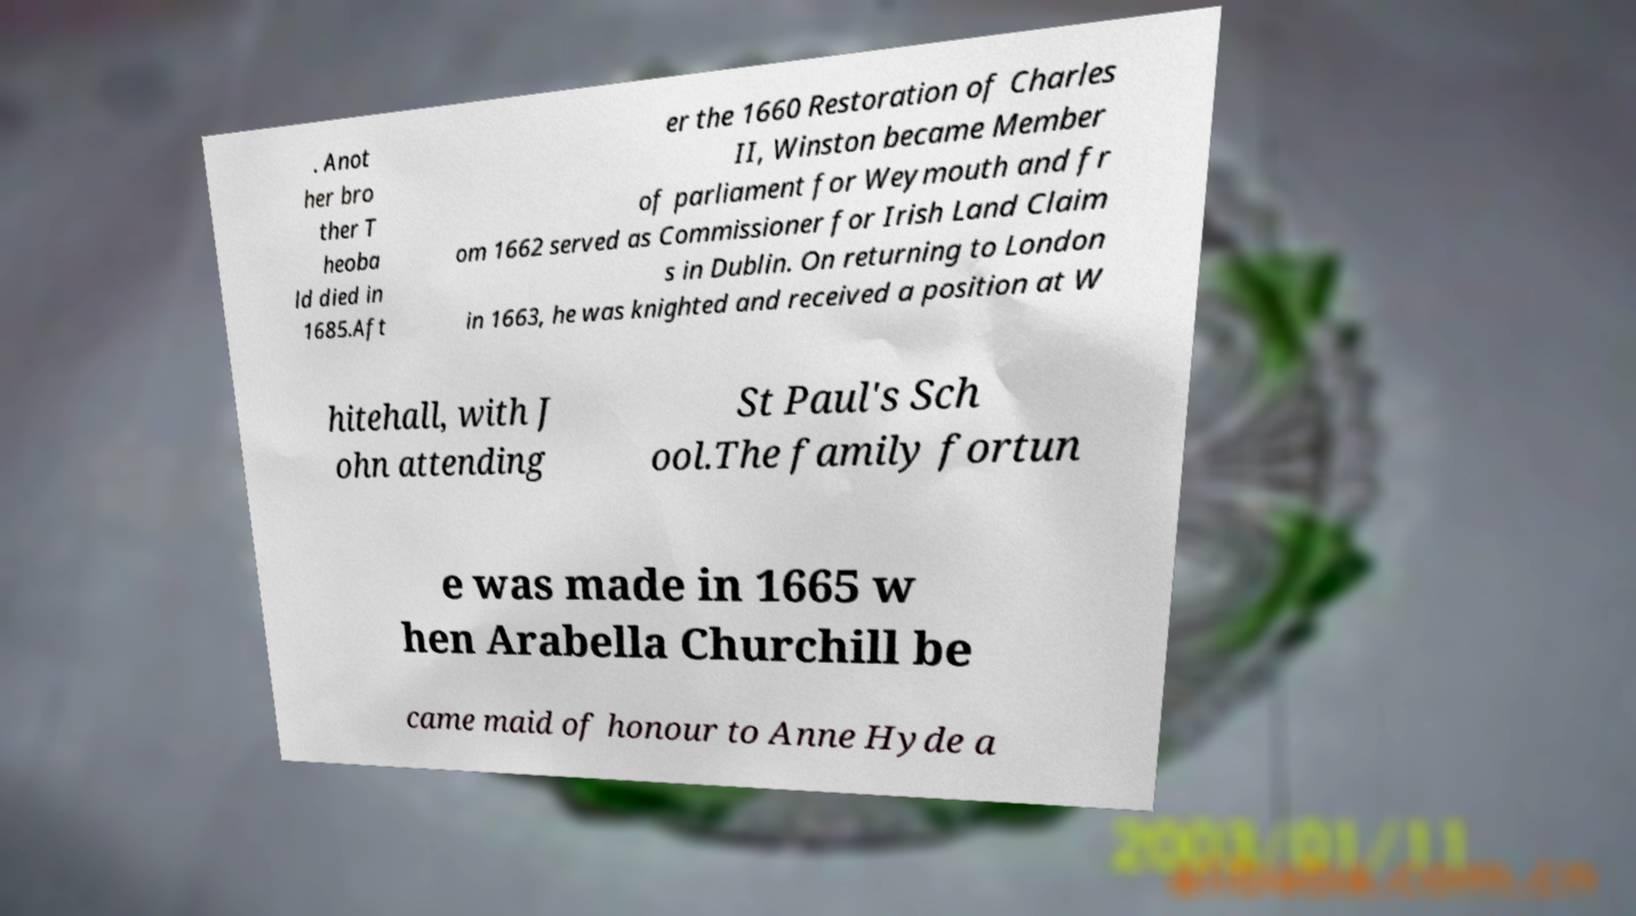Can you accurately transcribe the text from the provided image for me? . Anot her bro ther T heoba ld died in 1685.Aft er the 1660 Restoration of Charles II, Winston became Member of parliament for Weymouth and fr om 1662 served as Commissioner for Irish Land Claim s in Dublin. On returning to London in 1663, he was knighted and received a position at W hitehall, with J ohn attending St Paul's Sch ool.The family fortun e was made in 1665 w hen Arabella Churchill be came maid of honour to Anne Hyde a 